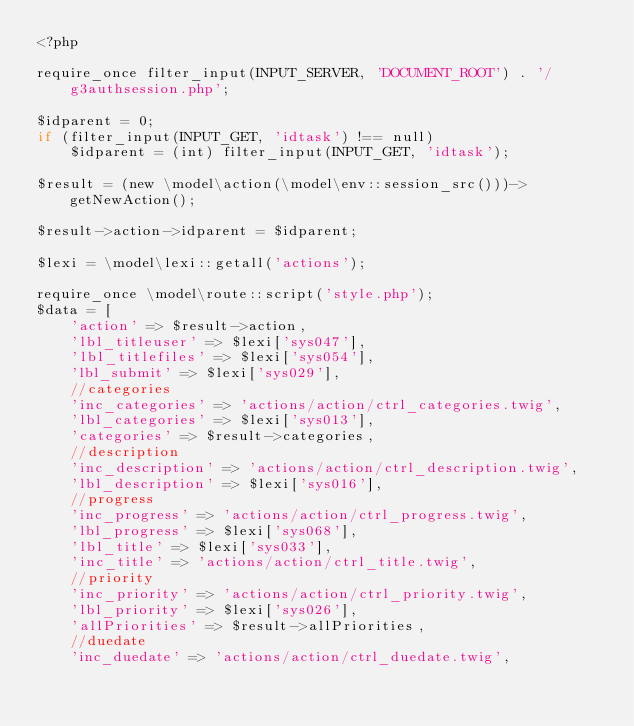Convert code to text. <code><loc_0><loc_0><loc_500><loc_500><_PHP_><?php

require_once filter_input(INPUT_SERVER, 'DOCUMENT_ROOT') . '/g3authsession.php';

$idparent = 0;
if (filter_input(INPUT_GET, 'idtask') !== null) 
    $idparent = (int) filter_input(INPUT_GET, 'idtask');

$result = (new \model\action(\model\env::session_src()))->getNewAction();

$result->action->idparent = $idparent;

$lexi = \model\lexi::getall('actions');

require_once \model\route::script('style.php');
$data = [
    'action' => $result->action,
    'lbl_titleuser' => $lexi['sys047'],
    'lbl_titlefiles' => $lexi['sys054'],
    'lbl_submit' => $lexi['sys029'],
    //categories
    'inc_categories' => 'actions/action/ctrl_categories.twig',
    'lbl_categories' => $lexi['sys013'],
    'categories' => $result->categories,
    //description
    'inc_description' => 'actions/action/ctrl_description.twig',
    'lbl_description' => $lexi['sys016'],
    //progress
    'inc_progress' => 'actions/action/ctrl_progress.twig',
    'lbl_progress' => $lexi['sys068'],
    'lbl_title' => $lexi['sys033'],
    'inc_title' => 'actions/action/ctrl_title.twig',
    //priority
    'inc_priority' => 'actions/action/ctrl_priority.twig',
    'lbl_priority' => $lexi['sys026'],
    'allPriorities' => $result->allPriorities,
    //duedate
    'inc_duedate' => 'actions/action/ctrl_duedate.twig',</code> 